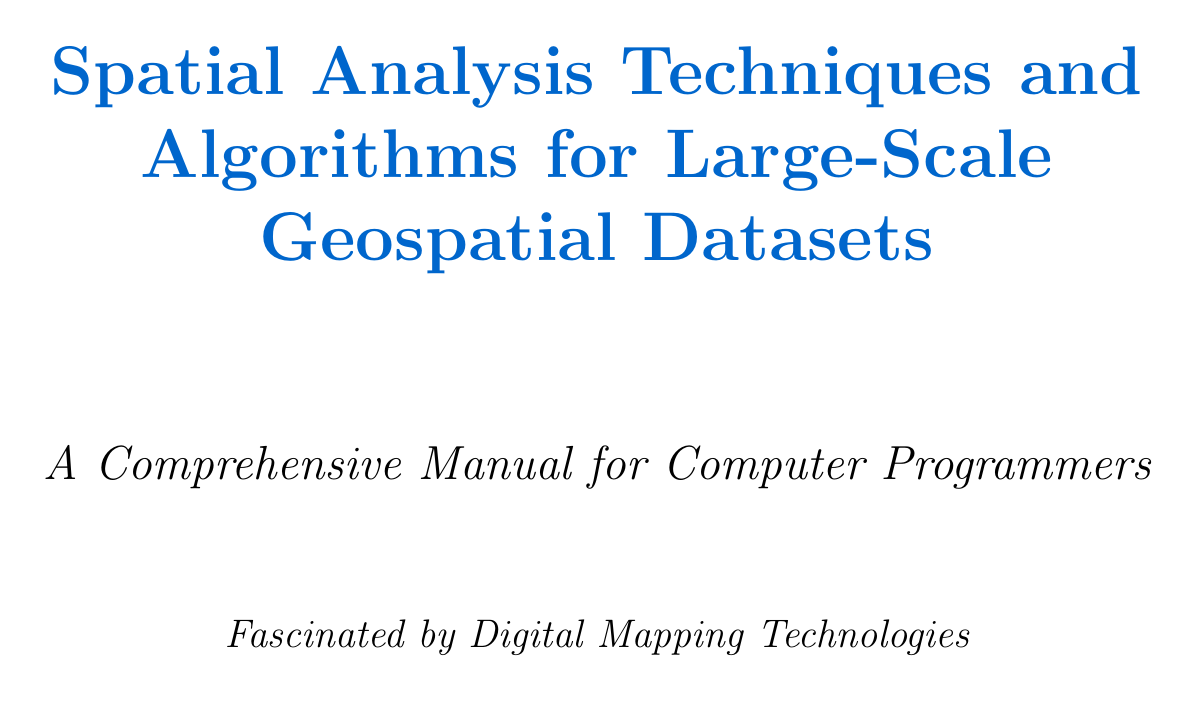What is the title of the manual? The title is explicitly stated at the beginning of the document.
Answer: Spatial Analysis Techniques and Algorithms for Large-Scale Geospatial Datasets How many chapters are in the document? The number of chapters is listed in the structure of the document.
Answer: Six What algorithm is mentioned for nearest neighbor search? The specific algorithm for nearest neighbor search is detailed in the section.
Answer: k-d trees Which programming library is referenced for visualizing 3D geospatial data? The library for 3D visualization is mentioned in the visualization section.
Answer: Cesium What type of data models are compared in the fundamentals section? The types of data models are explicitly named in the content.
Answer: Vector and Raster What geospatial extension for Hadoop is discussed? The extension for Hadoop is named in the big data processing chapter.
Answer: GeoMesa In which city is spatial analysis applied for urban planning in the document? The application of spatial analysis for urban planning specifies a city in the content.
Answer: New York City What is the focus of the conclusion in the document? The conclusion summarizes the key takeaway from the manual.
Answer: Mastering spatial analysis techniques What are two clustering algorithms mentioned in the document? The specific clustering algorithms are listed in the corresponding section.
Answer: DBSCAN and K-means 